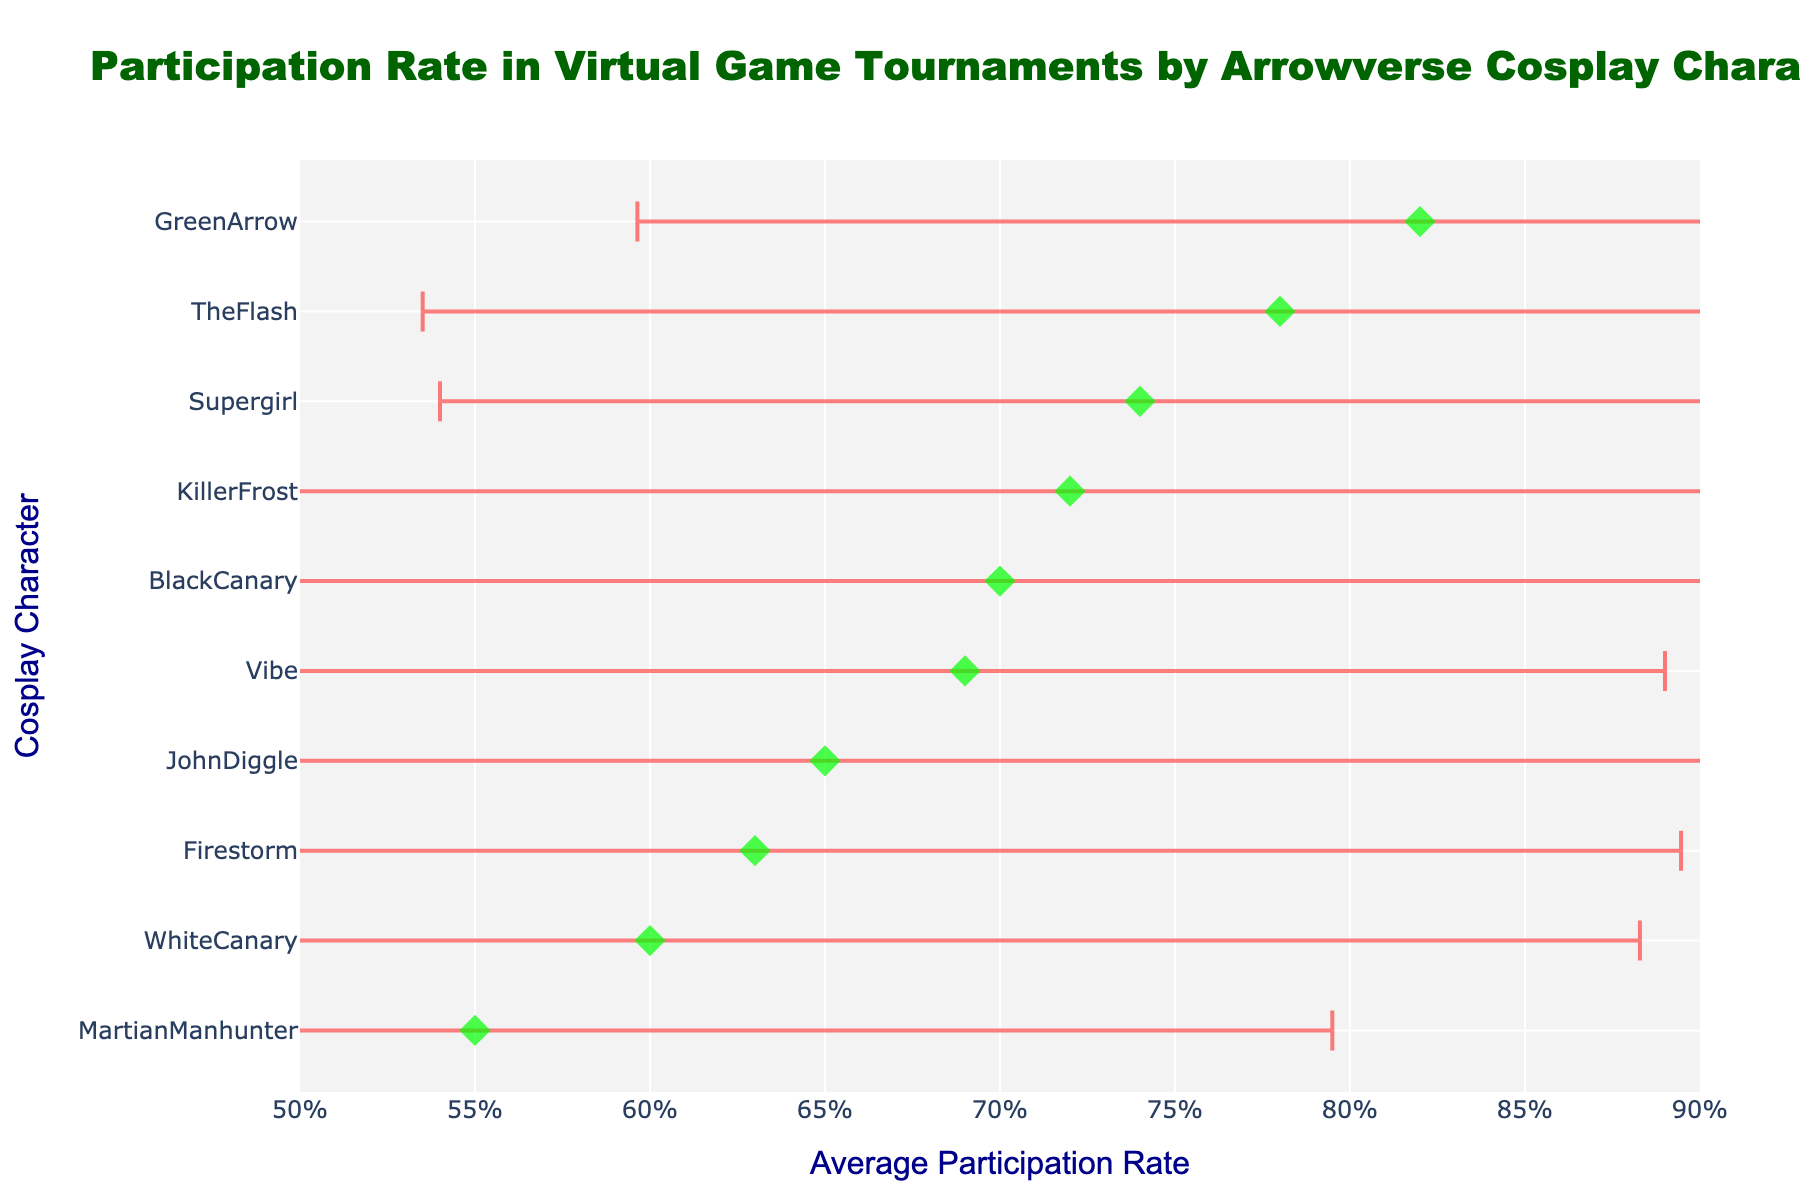What is the title of the figure? The title is usually displayed at the top of the figure. In this plot, it reads "Participation Rate in Virtual Game Tournaments by Arrowverse Cosplay Character."
Answer: Participation Rate in Virtual Game Tournaments by Arrowverse Cosplay Character Which cosplay character has the highest average participation rate? The character with the highest point on the x-axis represents the highest average participation rate. By checking each point, we see that Green Arrow has the highest average rate.
Answer: Green Arrow What is the average participation rate of Supergirl? Locate the point aligned with Supergirl on the y-axis and read its corresponding x-axis value. The average participation rate for Supergirl is 0.74.
Answer: 0.74 Which character has the lowest participation rate, and what is that rate? Find the character with the lowest point on the x-axis. The character is Martian Manhunter, and the rate is 0.55.
Answer: Martian Manhunter, 0.55 How does the participation rate of Killer Frost compare to that of The Flash? Find the points for Killer Frost and The Flash on the y-axis and compare their positions on the x-axis. Killer Frost has a participation rate of 0.72, while The Flash has 0.78.
Answer: The Flash has a higher rate than Killer Frost Which characters have error bars extending wider than 0.1? Error bars wider than 0.1 imply a standard deviation greater than approximately 0.1/2 = 0.05. Characters with wider error bars include John Diggle, White Canary, and Firestorm.
Answer: John Diggle, White Canary, Firestorm What is the value of the error bar for Black Canary? Identify the length of the error bar for Black Canary. The variance for Black Canary is 0.05; the standard deviation (error bar) is √0.05 ≈ 0.22.
Answer: ~0.22 Which character has the second-highest participation rate? The second highest rate is represented by the second farthest point to the right. The Flash has the second-highest participation rate after Green Arrow.
Answer: The Flash What is the range of participation rates shown in the figure? The range is the difference between the highest and lowest participation rates. The highest is 0.82 (Green Arrow), and the lowest is 0.55 (Martian Manhunter), so the range is 0.82 - 0.55 = 0.27.
Answer: 0.27 How much higher is Green Arrow's participation rate compared to Martian Manhunter's? Calculate the difference between the participation rates of Green Arrow (0.82) and Martian Manhunter (0.55). The difference is 0.82 - 0.55 = 0.27.
Answer: 0.27 